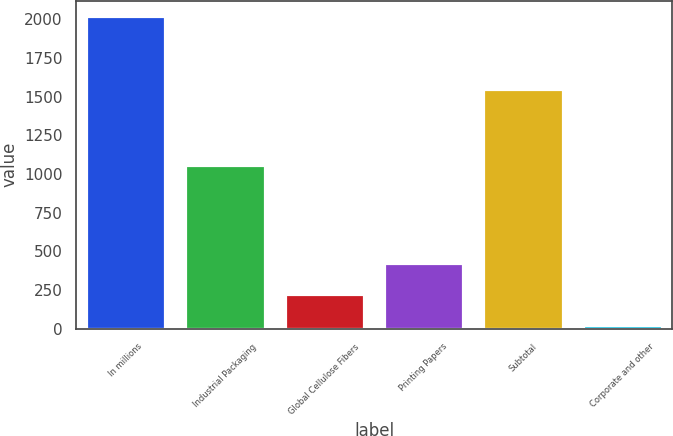Convert chart to OTSL. <chart><loc_0><loc_0><loc_500><loc_500><bar_chart><fcel>In millions<fcel>Industrial Packaging<fcel>Global Cellulose Fibers<fcel>Printing Papers<fcel>Subtotal<fcel>Corporate and other<nl><fcel>2018<fcel>1061<fcel>224.3<fcel>423.6<fcel>1547<fcel>25<nl></chart> 